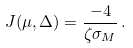<formula> <loc_0><loc_0><loc_500><loc_500>J ( \mu , \Delta ) = \frac { - 4 } { \zeta \sigma _ { M } } \, .</formula> 